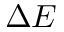Convert formula to latex. <formula><loc_0><loc_0><loc_500><loc_500>\Delta E</formula> 